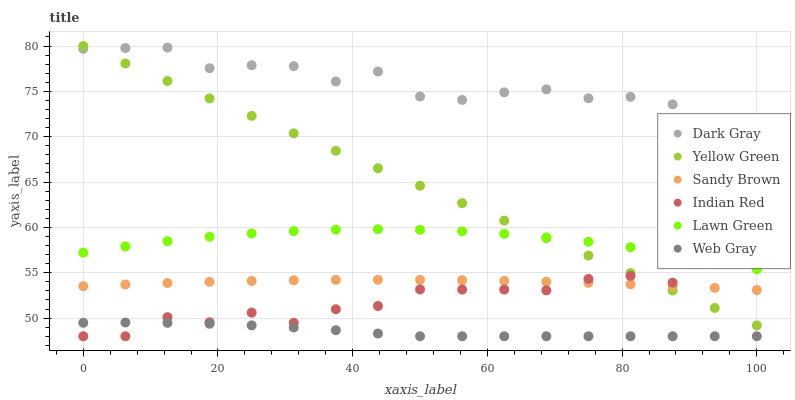Does Web Gray have the minimum area under the curve?
Answer yes or no. Yes. Does Dark Gray have the maximum area under the curve?
Answer yes or no. Yes. Does Yellow Green have the minimum area under the curve?
Answer yes or no. No. Does Yellow Green have the maximum area under the curve?
Answer yes or no. No. Is Yellow Green the smoothest?
Answer yes or no. Yes. Is Dark Gray the roughest?
Answer yes or no. Yes. Is Web Gray the smoothest?
Answer yes or no. No. Is Web Gray the roughest?
Answer yes or no. No. Does Web Gray have the lowest value?
Answer yes or no. Yes. Does Yellow Green have the lowest value?
Answer yes or no. No. Does Yellow Green have the highest value?
Answer yes or no. Yes. Does Web Gray have the highest value?
Answer yes or no. No. Is Web Gray less than Sandy Brown?
Answer yes or no. Yes. Is Lawn Green greater than Sandy Brown?
Answer yes or no. Yes. Does Sandy Brown intersect Indian Red?
Answer yes or no. Yes. Is Sandy Brown less than Indian Red?
Answer yes or no. No. Is Sandy Brown greater than Indian Red?
Answer yes or no. No. Does Web Gray intersect Sandy Brown?
Answer yes or no. No. 